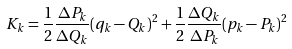Convert formula to latex. <formula><loc_0><loc_0><loc_500><loc_500>K _ { k } = \frac { 1 } { 2 } \frac { \Delta P _ { k } } { \Delta Q _ { k } } ( q _ { k } - Q _ { k } ) ^ { 2 } + \frac { 1 } { 2 } \frac { \Delta Q _ { k } } { \Delta P _ { k } } ( p _ { k } - P _ { k } ) ^ { 2 }</formula> 